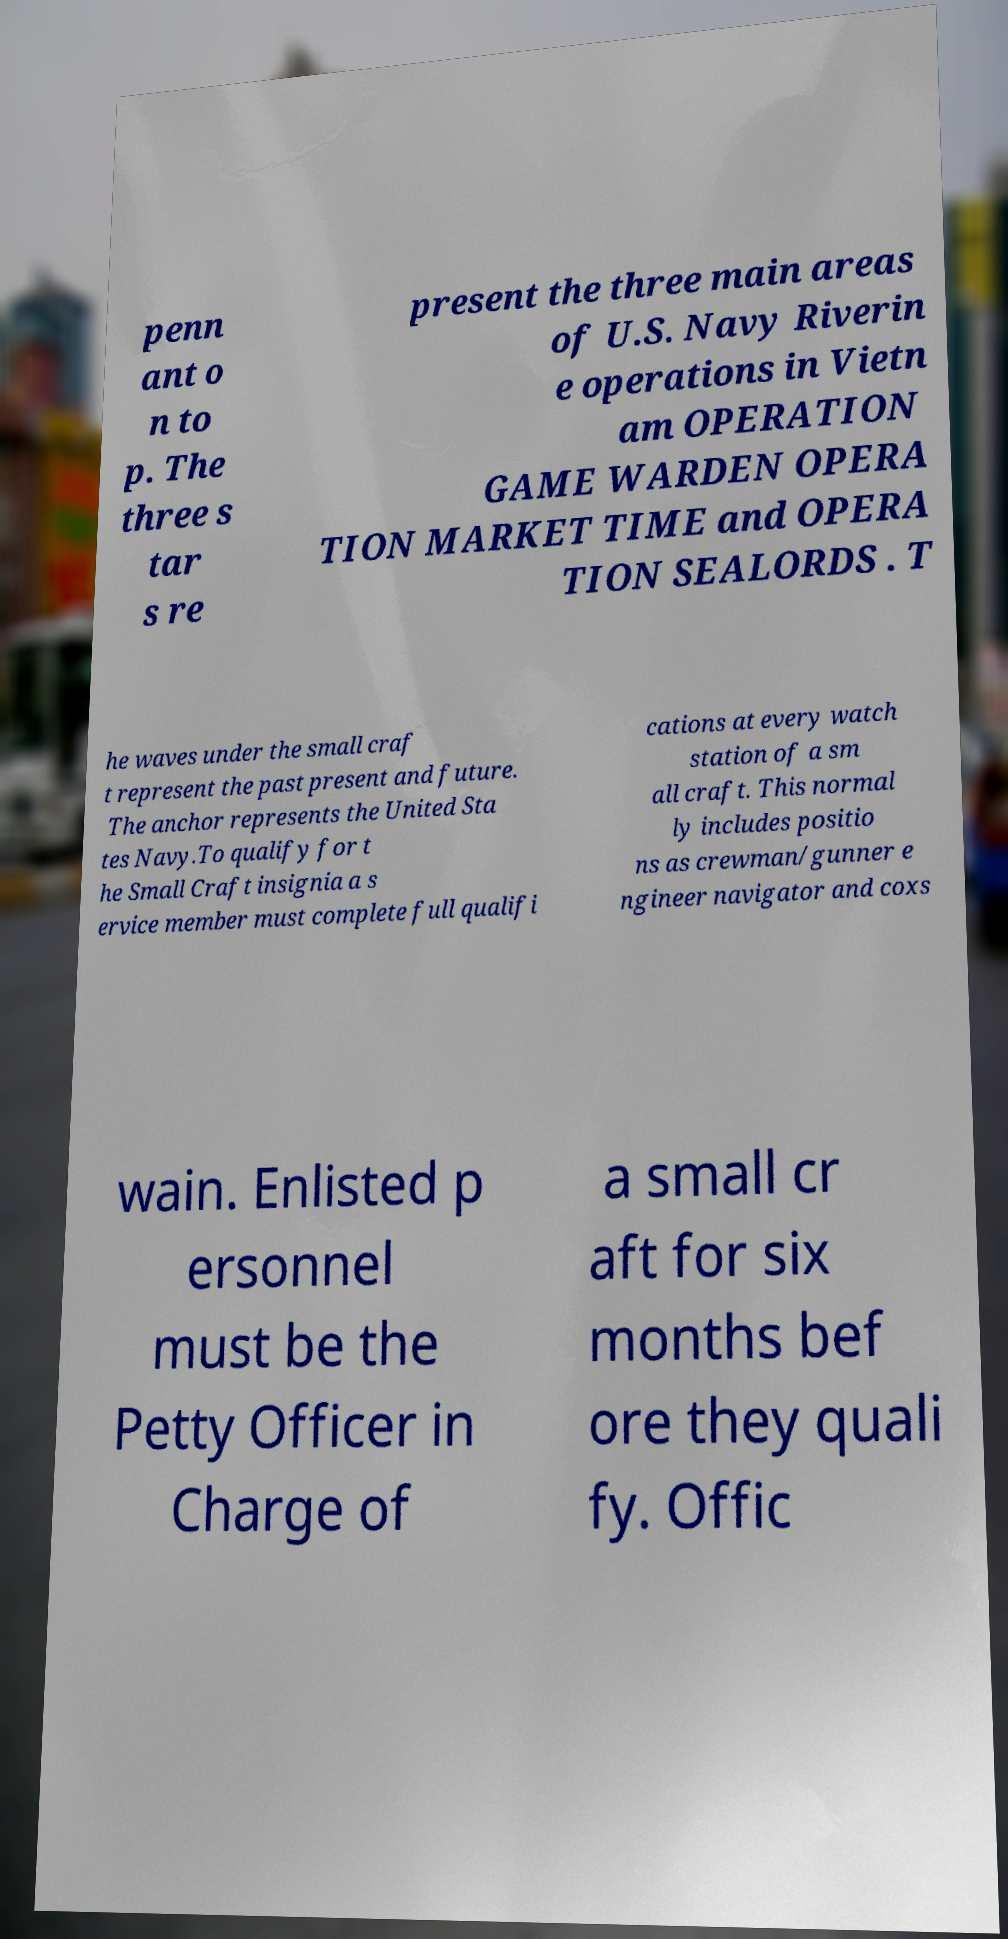For documentation purposes, I need the text within this image transcribed. Could you provide that? penn ant o n to p. The three s tar s re present the three main areas of U.S. Navy Riverin e operations in Vietn am OPERATION GAME WARDEN OPERA TION MARKET TIME and OPERA TION SEALORDS . T he waves under the small craf t represent the past present and future. The anchor represents the United Sta tes Navy.To qualify for t he Small Craft insignia a s ervice member must complete full qualifi cations at every watch station of a sm all craft. This normal ly includes positio ns as crewman/gunner e ngineer navigator and coxs wain. Enlisted p ersonnel must be the Petty Officer in Charge of a small cr aft for six months bef ore they quali fy. Offic 